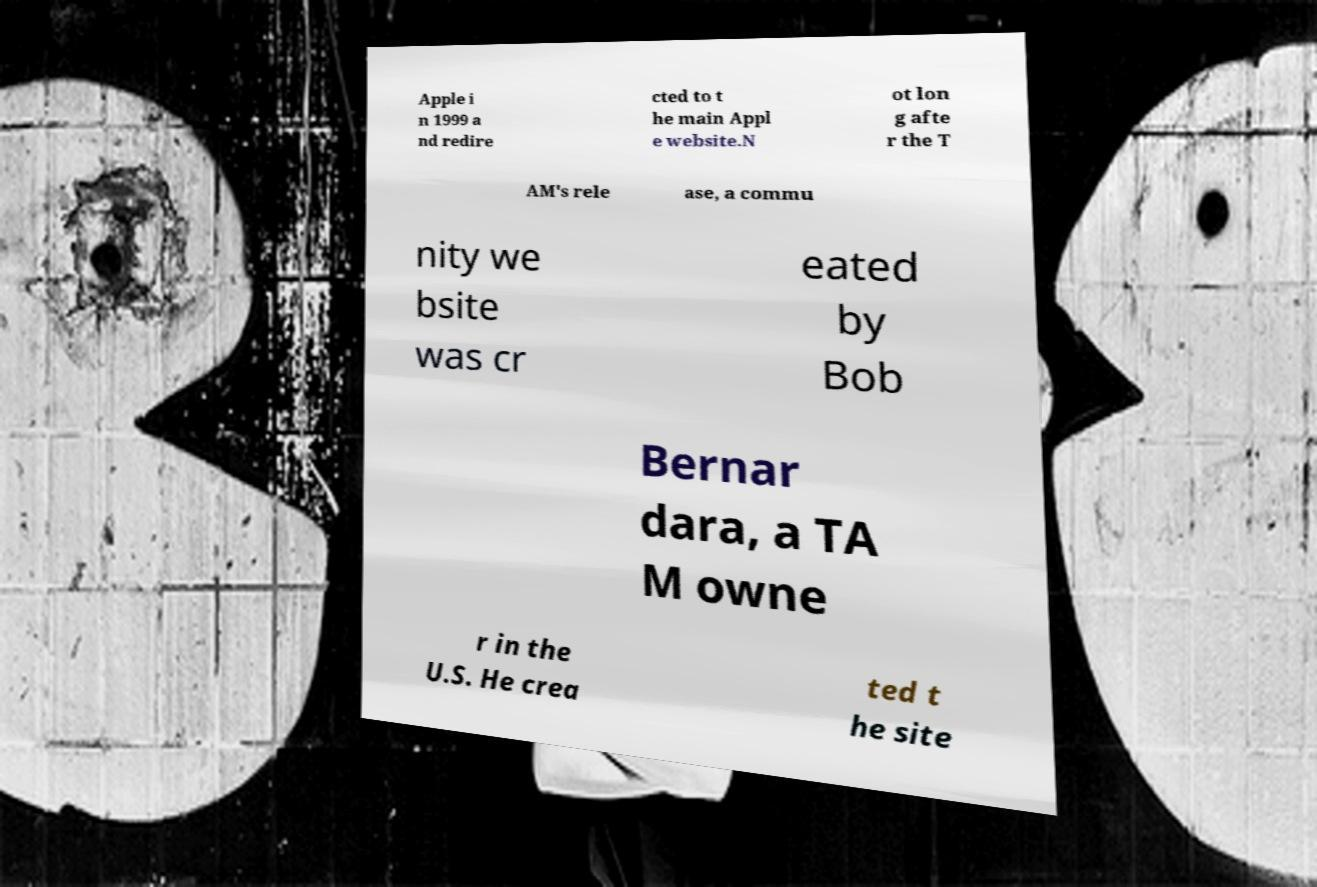Can you accurately transcribe the text from the provided image for me? Apple i n 1999 a nd redire cted to t he main Appl e website.N ot lon g afte r the T AM's rele ase, a commu nity we bsite was cr eated by Bob Bernar dara, a TA M owne r in the U.S. He crea ted t he site 